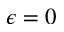<formula> <loc_0><loc_0><loc_500><loc_500>\epsilon = 0</formula> 